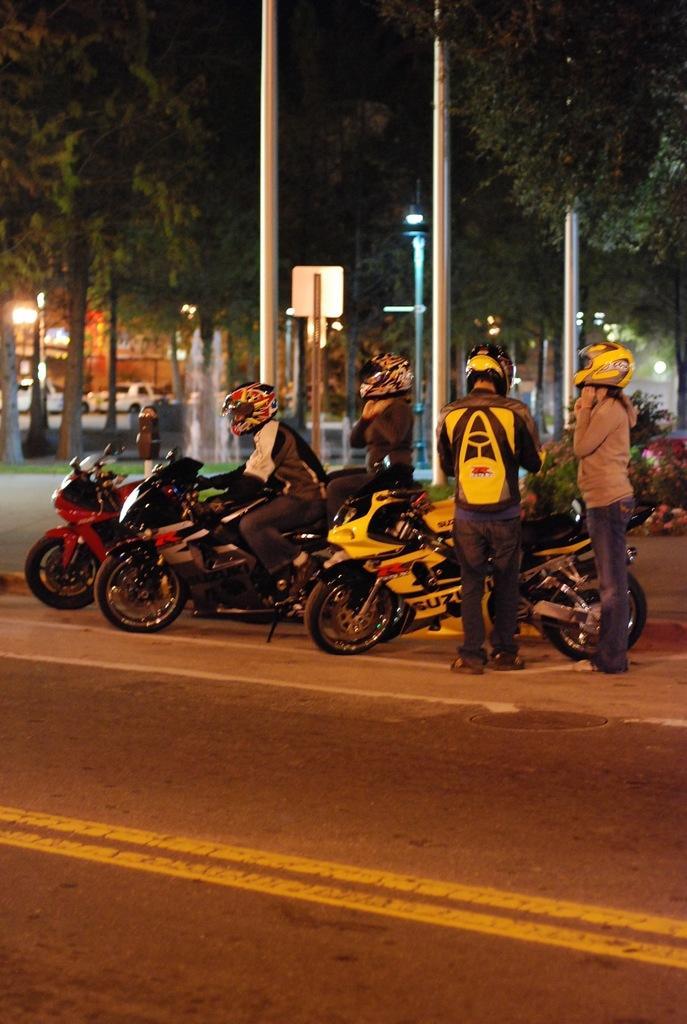In one or two sentences, can you explain what this image depicts? This is a picture where we have three bikes and four people with helmets wearing backpacks and there are some trees and poles around them. 